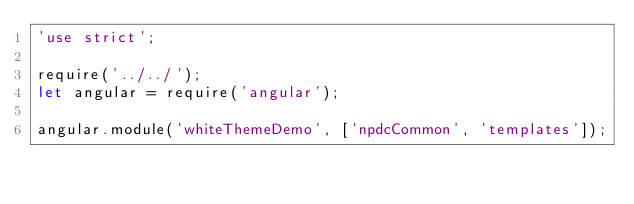Convert code to text. <code><loc_0><loc_0><loc_500><loc_500><_JavaScript_>'use strict';

require('../../');
let angular = require('angular');

angular.module('whiteThemeDemo', ['npdcCommon', 'templates']);
</code> 